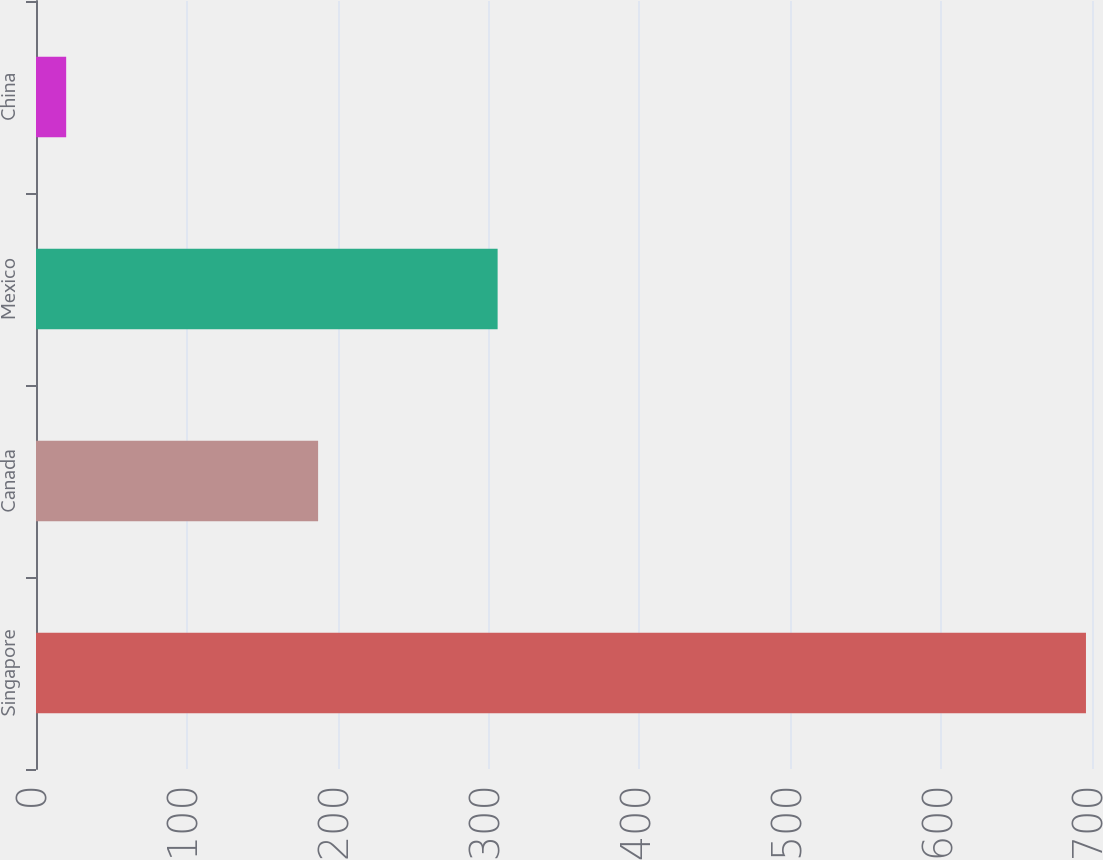Convert chart to OTSL. <chart><loc_0><loc_0><loc_500><loc_500><bar_chart><fcel>Singapore<fcel>Canada<fcel>Mexico<fcel>China<nl><fcel>696<fcel>187<fcel>306<fcel>20<nl></chart> 